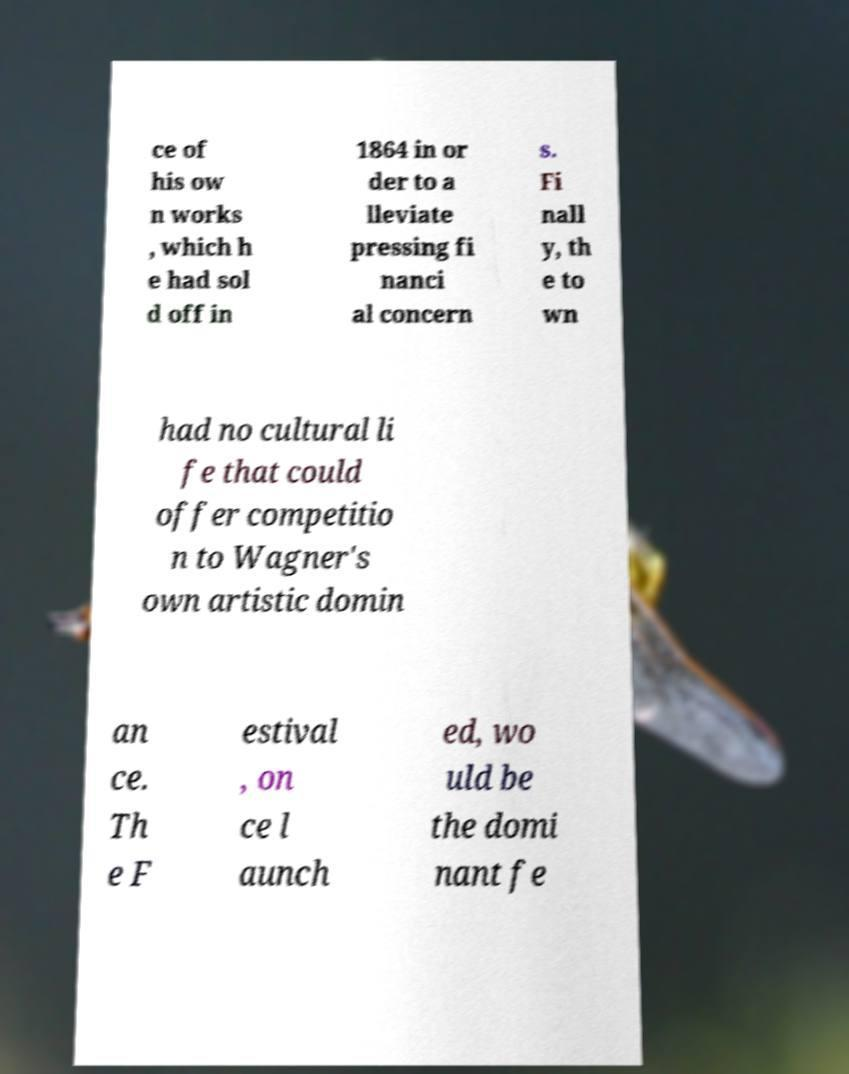Can you accurately transcribe the text from the provided image for me? ce of his ow n works , which h e had sol d off in 1864 in or der to a lleviate pressing fi nanci al concern s. Fi nall y, th e to wn had no cultural li fe that could offer competitio n to Wagner's own artistic domin an ce. Th e F estival , on ce l aunch ed, wo uld be the domi nant fe 